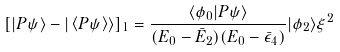<formula> <loc_0><loc_0><loc_500><loc_500>[ | P \psi \rangle - | \left \langle P \psi \right \rangle \rangle ] _ { 1 } = \frac { \langle \phi _ { 0 } | P \psi \rangle } { ( E _ { 0 } - \bar { E } _ { 2 } ) ( E _ { 0 } - \bar { \epsilon } _ { 4 } ) } | \phi _ { 2 } \rangle \xi ^ { 2 }</formula> 